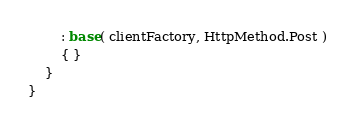<code> <loc_0><loc_0><loc_500><loc_500><_C#_>        : base( clientFactory, HttpMethod.Post )
        { }
    }
}
</code> 